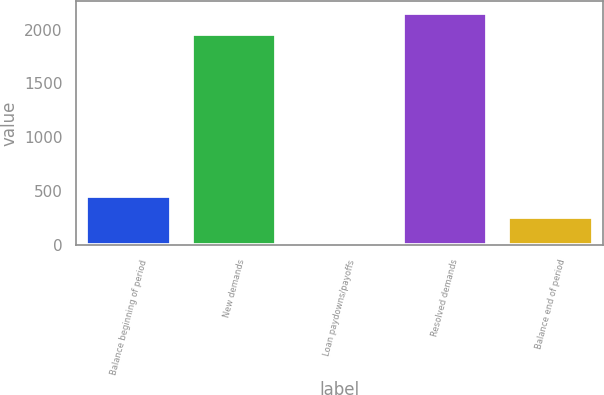Convert chart. <chart><loc_0><loc_0><loc_500><loc_500><bar_chart><fcel>Balance beginning of period<fcel>New demands<fcel>Loan paydowns/payoffs<fcel>Resolved demands<fcel>Balance end of period<nl><fcel>459.2<fcel>1962<fcel>20<fcel>2157.2<fcel>264<nl></chart> 